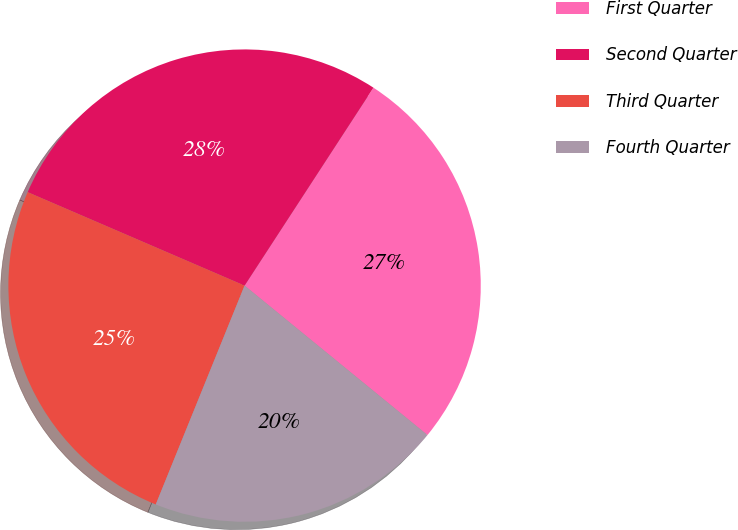Convert chart to OTSL. <chart><loc_0><loc_0><loc_500><loc_500><pie_chart><fcel>First Quarter<fcel>Second Quarter<fcel>Third Quarter<fcel>Fourth Quarter<nl><fcel>26.72%<fcel>27.71%<fcel>25.34%<fcel>20.23%<nl></chart> 